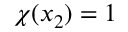<formula> <loc_0><loc_0><loc_500><loc_500>\chi ( x _ { 2 } ) = 1</formula> 